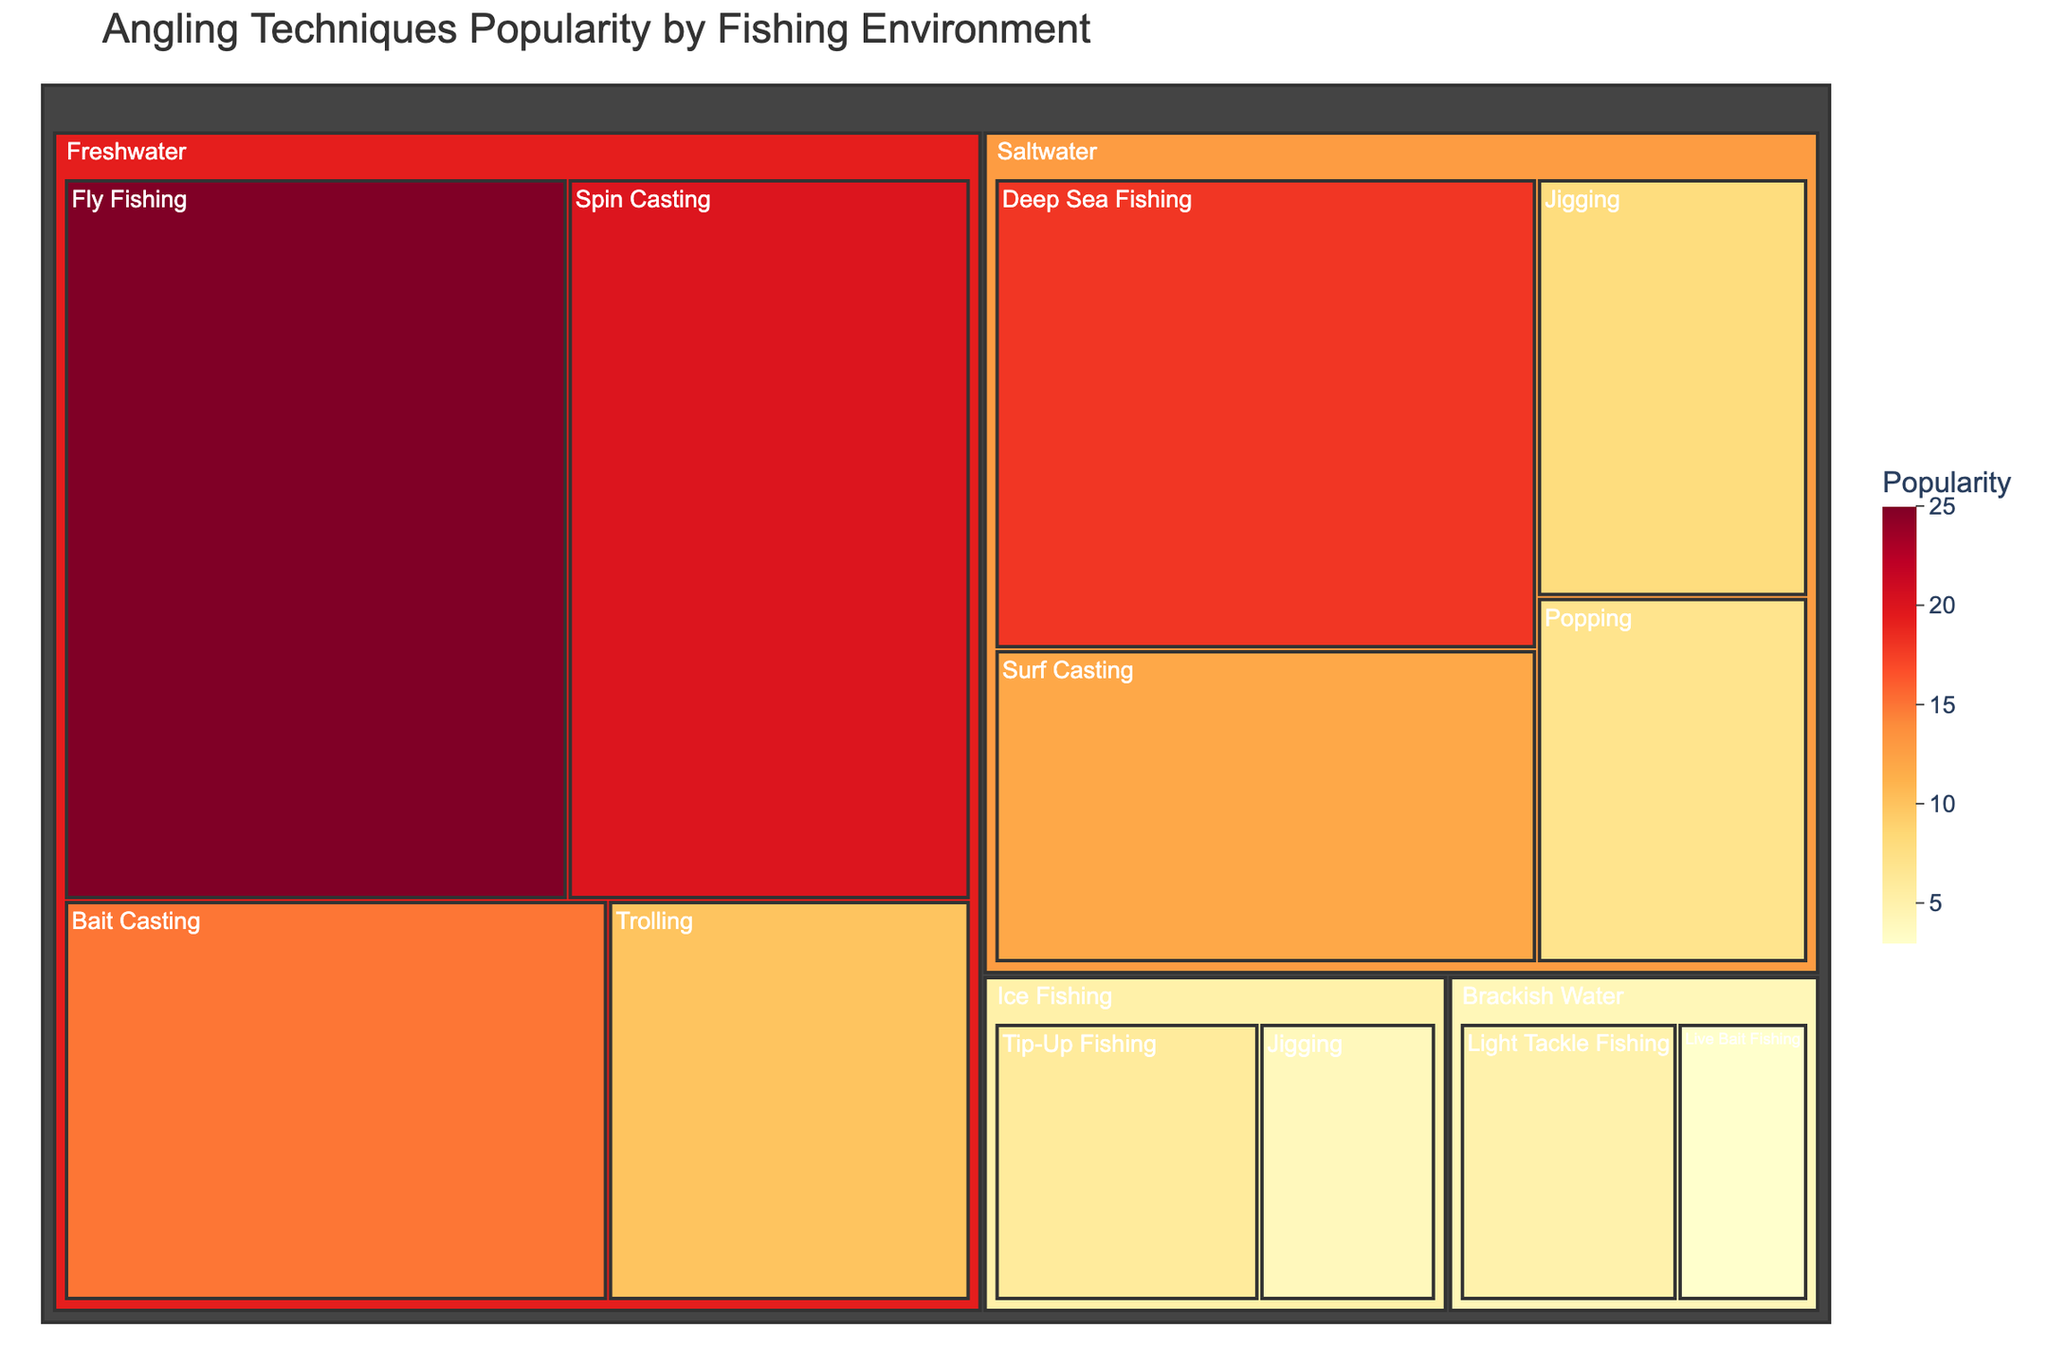What is the title of the treemap? The title is placed at the top of the treemap, typically in larger font and often a different color to stand out.
Answer: Angling Techniques Popularity by Fishing Environment Which fishing technique has the highest popularity in freshwater environments? To find this, look into the "Freshwater" category and identify the technique with the largest area or highest value, which is colored most brightly.
Answer: Fly Fishing How does the popularity of Spin Casting in freshwater compare to Surf Casting in saltwater? Locate the areas labeled "Spin Casting" within "Freshwater" and "Surf Casting" within "Saltwater" and compare the values. Spin Casting has 20 and Surf Casting has 12.
Answer: Spin Casting (20) is more popular than Surf Casting (12) What is the total popularity of all techniques in saltwater environments? Sum the popularity values of all techniques under the "Saltwater" category: Deep Sea Fishing (18) + Surf Casting (12) + Jigging (8) + Popping (7).
Answer: 45 Between Fly Fishing and Deep Sea Fishing, which technique has greater popularity, and by how much? Compare the popularity values for Fly Fishing (25) under "Freshwater" and Deep Sea Fishing (18) under "Saltwater", then calculate the difference. 25 - 18 = 7.
Answer: Fly Fishing is more popular by 7 Which fishing environment has the least popular technique and what is it? Look for the smallest area or value in the treemap across all categories. The smallest value is for "Live Bait Fishing" in "Brackish Water" with a popularity of 3.
Answer: Brackish Water, Live Bait Fishing What is the combined popularity of all types of Jigging in the treemap? Sum the popularity values for "Jigging" in different environments: Saltwater (8) + Ice Fishing (4).
Answer: 12 Among all environments, which one has the highest combined popularity for all angling techniques? Sum the popularity values for each environment and compare: Freshwater (25 + 20 + 15 + 10 = 70), Saltwater (18 + 12 + 8 + 7 = 45), Ice Fishing (6 + 4 = 10), Brackish Water (5 + 3 = 8). Freshwater has the sum of 70.
Answer: Freshwater Which environment has more overall popularity, Ice Fishing or Brackish Water? Compare the combined popularity values: Ice Fishing (6 + 4 = 10), Brackish Water (5 + 3 = 8).
Answer: Ice Fishing (10) is more popular than Brackish Water (8) 